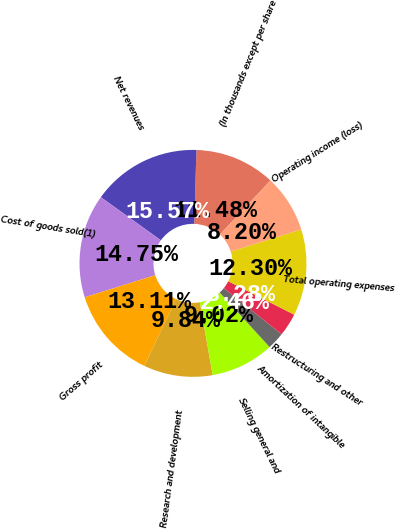Convert chart to OTSL. <chart><loc_0><loc_0><loc_500><loc_500><pie_chart><fcel>(In thousands except per share<fcel>Net revenues<fcel>Cost of goods sold(1)<fcel>Gross profit<fcel>Research and development<fcel>Selling general and<fcel>Amortization of intangible<fcel>Restructuring and other<fcel>Total operating expenses<fcel>Operating income (loss)<nl><fcel>11.48%<fcel>15.57%<fcel>14.75%<fcel>13.11%<fcel>9.84%<fcel>9.02%<fcel>2.46%<fcel>3.28%<fcel>12.3%<fcel>8.2%<nl></chart> 